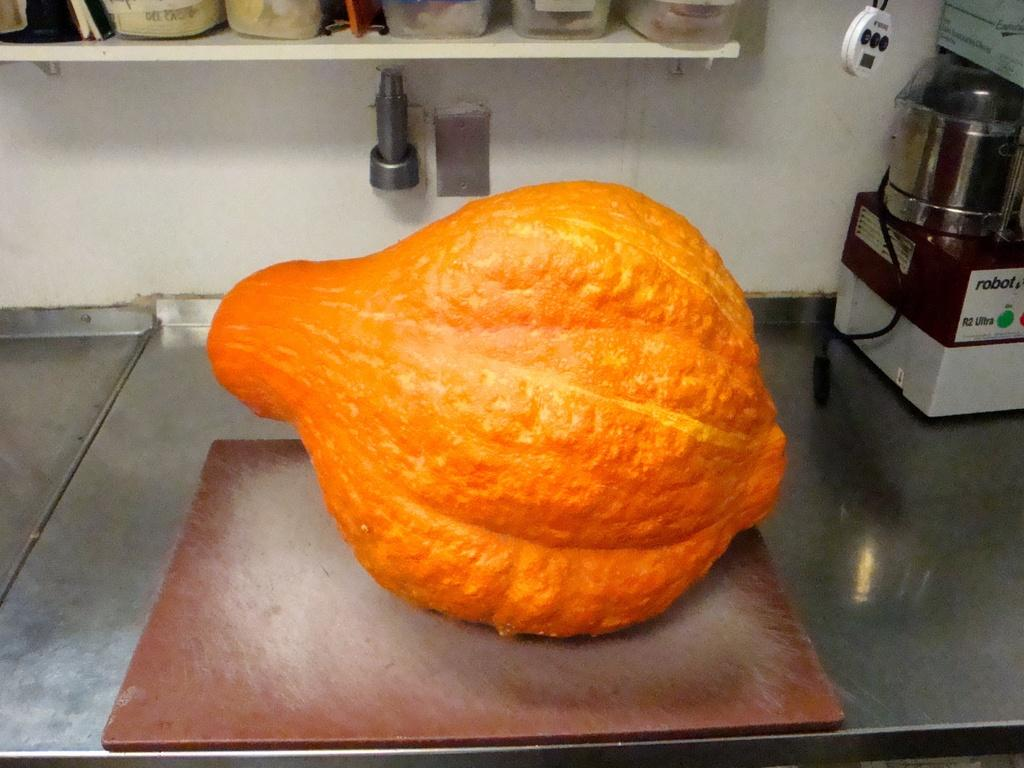<image>
Render a clear and concise summary of the photo. A kitchen appliance labeled robot is shown just off to the right behind a large orange gourd. 